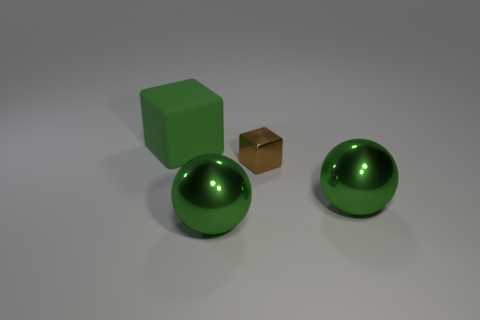Add 3 green shiny things. How many objects exist? 7 Subtract all green blocks. How many blocks are left? 1 Subtract 2 spheres. How many spheres are left? 0 Subtract all green cubes. Subtract all brown cylinders. How many cubes are left? 1 Subtract all brown things. Subtract all tiny cyan cylinders. How many objects are left? 3 Add 4 green balls. How many green balls are left? 6 Add 3 small blue metallic things. How many small blue metallic things exist? 3 Subtract 0 cyan blocks. How many objects are left? 4 